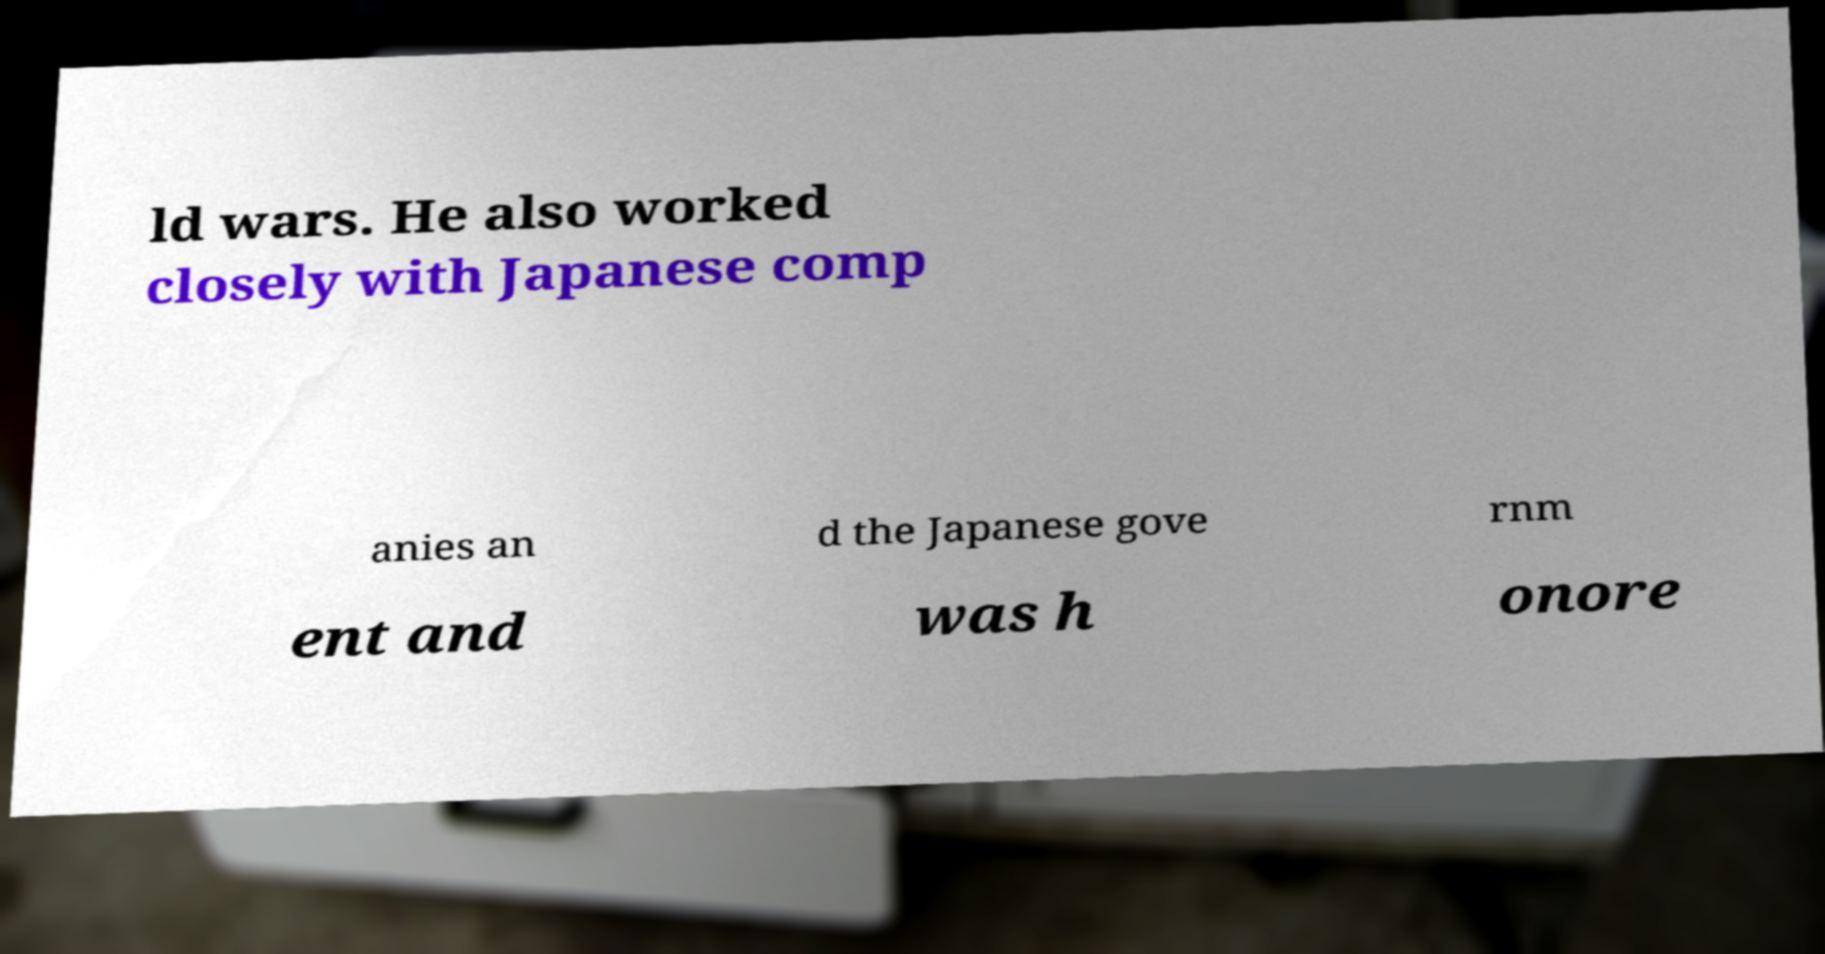For documentation purposes, I need the text within this image transcribed. Could you provide that? ld wars. He also worked closely with Japanese comp anies an d the Japanese gove rnm ent and was h onore 